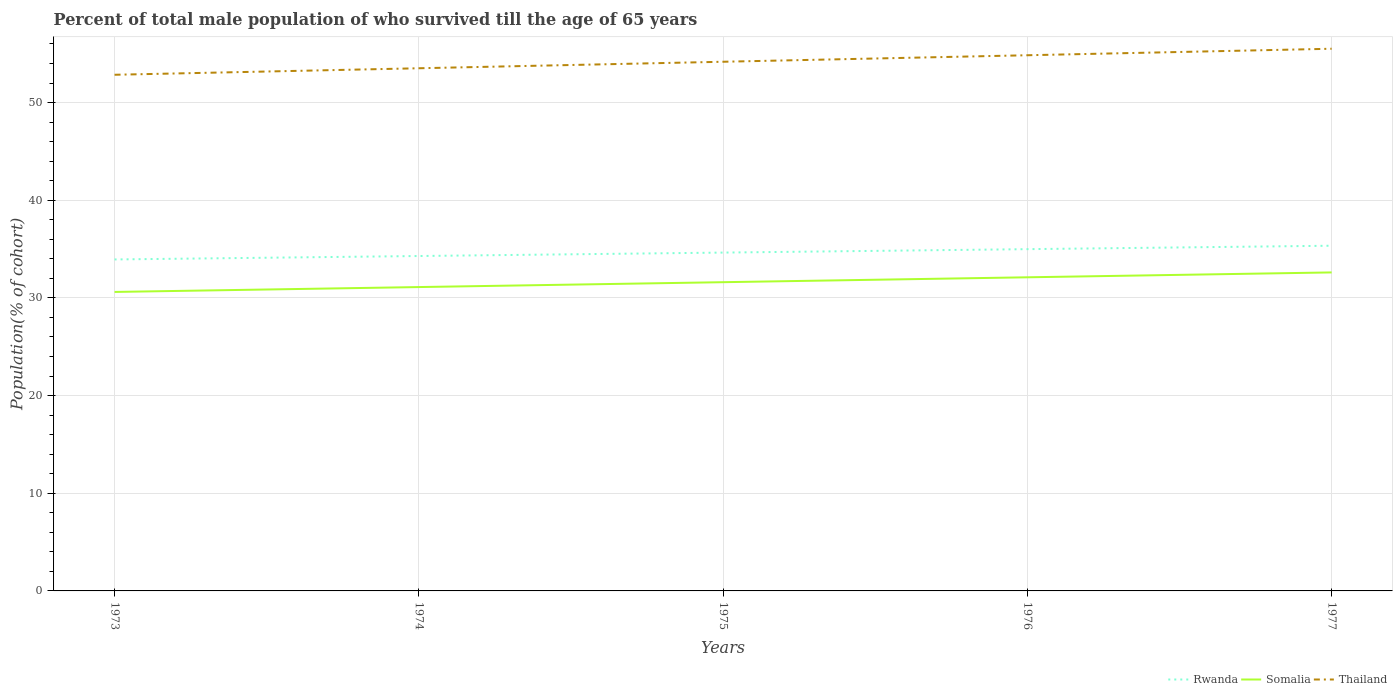How many different coloured lines are there?
Keep it short and to the point. 3. Does the line corresponding to Rwanda intersect with the line corresponding to Somalia?
Provide a short and direct response. No. Across all years, what is the maximum percentage of total male population who survived till the age of 65 years in Thailand?
Keep it short and to the point. 52.85. In which year was the percentage of total male population who survived till the age of 65 years in Somalia maximum?
Provide a short and direct response. 1973. What is the total percentage of total male population who survived till the age of 65 years in Rwanda in the graph?
Your answer should be compact. -1.05. What is the difference between the highest and the second highest percentage of total male population who survived till the age of 65 years in Rwanda?
Ensure brevity in your answer.  1.4. What is the difference between the highest and the lowest percentage of total male population who survived till the age of 65 years in Thailand?
Provide a succinct answer. 2. Is the percentage of total male population who survived till the age of 65 years in Thailand strictly greater than the percentage of total male population who survived till the age of 65 years in Rwanda over the years?
Your response must be concise. No. How many lines are there?
Give a very brief answer. 3. Are the values on the major ticks of Y-axis written in scientific E-notation?
Offer a terse response. No. Where does the legend appear in the graph?
Offer a very short reply. Bottom right. What is the title of the graph?
Give a very brief answer. Percent of total male population of who survived till the age of 65 years. Does "Dominican Republic" appear as one of the legend labels in the graph?
Keep it short and to the point. No. What is the label or title of the Y-axis?
Your answer should be very brief. Population(% of cohort). What is the Population(% of cohort) of Rwanda in 1973?
Keep it short and to the point. 33.94. What is the Population(% of cohort) of Somalia in 1973?
Offer a terse response. 30.61. What is the Population(% of cohort) in Thailand in 1973?
Offer a very short reply. 52.85. What is the Population(% of cohort) in Rwanda in 1974?
Your answer should be very brief. 34.29. What is the Population(% of cohort) in Somalia in 1974?
Keep it short and to the point. 31.11. What is the Population(% of cohort) in Thailand in 1974?
Your answer should be very brief. 53.51. What is the Population(% of cohort) in Rwanda in 1975?
Provide a succinct answer. 34.64. What is the Population(% of cohort) in Somalia in 1975?
Your answer should be compact. 31.61. What is the Population(% of cohort) in Thailand in 1975?
Your answer should be very brief. 54.18. What is the Population(% of cohort) of Rwanda in 1976?
Your answer should be compact. 34.99. What is the Population(% of cohort) in Somalia in 1976?
Your answer should be compact. 32.11. What is the Population(% of cohort) of Thailand in 1976?
Ensure brevity in your answer.  54.85. What is the Population(% of cohort) of Rwanda in 1977?
Provide a succinct answer. 35.34. What is the Population(% of cohort) in Somalia in 1977?
Give a very brief answer. 32.61. What is the Population(% of cohort) in Thailand in 1977?
Give a very brief answer. 55.51. Across all years, what is the maximum Population(% of cohort) in Rwanda?
Provide a succinct answer. 35.34. Across all years, what is the maximum Population(% of cohort) in Somalia?
Keep it short and to the point. 32.61. Across all years, what is the maximum Population(% of cohort) in Thailand?
Your response must be concise. 55.51. Across all years, what is the minimum Population(% of cohort) of Rwanda?
Ensure brevity in your answer.  33.94. Across all years, what is the minimum Population(% of cohort) in Somalia?
Your answer should be very brief. 30.61. Across all years, what is the minimum Population(% of cohort) in Thailand?
Keep it short and to the point. 52.85. What is the total Population(% of cohort) of Rwanda in the graph?
Your answer should be compact. 173.2. What is the total Population(% of cohort) of Somalia in the graph?
Your answer should be compact. 158.05. What is the total Population(% of cohort) of Thailand in the graph?
Provide a succinct answer. 270.89. What is the difference between the Population(% of cohort) of Rwanda in 1973 and that in 1974?
Provide a short and direct response. -0.35. What is the difference between the Population(% of cohort) of Somalia in 1973 and that in 1974?
Your response must be concise. -0.5. What is the difference between the Population(% of cohort) in Thailand in 1973 and that in 1974?
Your response must be concise. -0.67. What is the difference between the Population(% of cohort) of Rwanda in 1973 and that in 1975?
Offer a very short reply. -0.7. What is the difference between the Population(% of cohort) in Somalia in 1973 and that in 1975?
Offer a very short reply. -1. What is the difference between the Population(% of cohort) in Thailand in 1973 and that in 1975?
Give a very brief answer. -1.33. What is the difference between the Population(% of cohort) of Rwanda in 1973 and that in 1976?
Offer a terse response. -1.05. What is the difference between the Population(% of cohort) in Somalia in 1973 and that in 1976?
Offer a terse response. -1.5. What is the difference between the Population(% of cohort) of Thailand in 1973 and that in 1976?
Your answer should be very brief. -2. What is the difference between the Population(% of cohort) of Rwanda in 1973 and that in 1977?
Your answer should be very brief. -1.4. What is the difference between the Population(% of cohort) of Somalia in 1973 and that in 1977?
Your answer should be very brief. -2. What is the difference between the Population(% of cohort) in Thailand in 1973 and that in 1977?
Keep it short and to the point. -2.66. What is the difference between the Population(% of cohort) in Rwanda in 1974 and that in 1975?
Provide a short and direct response. -0.35. What is the difference between the Population(% of cohort) of Somalia in 1974 and that in 1975?
Offer a very short reply. -0.5. What is the difference between the Population(% of cohort) of Thailand in 1974 and that in 1975?
Ensure brevity in your answer.  -0.67. What is the difference between the Population(% of cohort) of Rwanda in 1974 and that in 1976?
Keep it short and to the point. -0.7. What is the difference between the Population(% of cohort) of Somalia in 1974 and that in 1976?
Your response must be concise. -1. What is the difference between the Population(% of cohort) of Thailand in 1974 and that in 1976?
Provide a succinct answer. -1.33. What is the difference between the Population(% of cohort) of Rwanda in 1974 and that in 1977?
Give a very brief answer. -1.05. What is the difference between the Population(% of cohort) in Somalia in 1974 and that in 1977?
Provide a succinct answer. -1.5. What is the difference between the Population(% of cohort) of Thailand in 1974 and that in 1977?
Ensure brevity in your answer.  -2. What is the difference between the Population(% of cohort) in Rwanda in 1975 and that in 1976?
Offer a terse response. -0.35. What is the difference between the Population(% of cohort) of Somalia in 1975 and that in 1976?
Your answer should be compact. -0.5. What is the difference between the Population(% of cohort) in Thailand in 1975 and that in 1976?
Offer a terse response. -0.67. What is the difference between the Population(% of cohort) of Rwanda in 1975 and that in 1977?
Ensure brevity in your answer.  -0.7. What is the difference between the Population(% of cohort) in Somalia in 1975 and that in 1977?
Keep it short and to the point. -1. What is the difference between the Population(% of cohort) in Thailand in 1975 and that in 1977?
Provide a short and direct response. -1.33. What is the difference between the Population(% of cohort) in Rwanda in 1976 and that in 1977?
Give a very brief answer. -0.35. What is the difference between the Population(% of cohort) in Somalia in 1976 and that in 1977?
Make the answer very short. -0.5. What is the difference between the Population(% of cohort) in Thailand in 1976 and that in 1977?
Ensure brevity in your answer.  -0.67. What is the difference between the Population(% of cohort) in Rwanda in 1973 and the Population(% of cohort) in Somalia in 1974?
Your answer should be very brief. 2.83. What is the difference between the Population(% of cohort) in Rwanda in 1973 and the Population(% of cohort) in Thailand in 1974?
Ensure brevity in your answer.  -19.57. What is the difference between the Population(% of cohort) in Somalia in 1973 and the Population(% of cohort) in Thailand in 1974?
Offer a very short reply. -22.9. What is the difference between the Population(% of cohort) of Rwanda in 1973 and the Population(% of cohort) of Somalia in 1975?
Provide a short and direct response. 2.33. What is the difference between the Population(% of cohort) in Rwanda in 1973 and the Population(% of cohort) in Thailand in 1975?
Provide a succinct answer. -20.24. What is the difference between the Population(% of cohort) of Somalia in 1973 and the Population(% of cohort) of Thailand in 1975?
Offer a very short reply. -23.57. What is the difference between the Population(% of cohort) in Rwanda in 1973 and the Population(% of cohort) in Somalia in 1976?
Provide a succinct answer. 1.83. What is the difference between the Population(% of cohort) in Rwanda in 1973 and the Population(% of cohort) in Thailand in 1976?
Ensure brevity in your answer.  -20.91. What is the difference between the Population(% of cohort) of Somalia in 1973 and the Population(% of cohort) of Thailand in 1976?
Provide a succinct answer. -24.23. What is the difference between the Population(% of cohort) in Rwanda in 1973 and the Population(% of cohort) in Somalia in 1977?
Ensure brevity in your answer.  1.33. What is the difference between the Population(% of cohort) in Rwanda in 1973 and the Population(% of cohort) in Thailand in 1977?
Your response must be concise. -21.57. What is the difference between the Population(% of cohort) of Somalia in 1973 and the Population(% of cohort) of Thailand in 1977?
Give a very brief answer. -24.9. What is the difference between the Population(% of cohort) of Rwanda in 1974 and the Population(% of cohort) of Somalia in 1975?
Offer a terse response. 2.68. What is the difference between the Population(% of cohort) of Rwanda in 1974 and the Population(% of cohort) of Thailand in 1975?
Offer a very short reply. -19.89. What is the difference between the Population(% of cohort) in Somalia in 1974 and the Population(% of cohort) in Thailand in 1975?
Your response must be concise. -23.07. What is the difference between the Population(% of cohort) in Rwanda in 1974 and the Population(% of cohort) in Somalia in 1976?
Your response must be concise. 2.18. What is the difference between the Population(% of cohort) of Rwanda in 1974 and the Population(% of cohort) of Thailand in 1976?
Your answer should be compact. -20.56. What is the difference between the Population(% of cohort) of Somalia in 1974 and the Population(% of cohort) of Thailand in 1976?
Offer a very short reply. -23.73. What is the difference between the Population(% of cohort) in Rwanda in 1974 and the Population(% of cohort) in Somalia in 1977?
Keep it short and to the point. 1.68. What is the difference between the Population(% of cohort) in Rwanda in 1974 and the Population(% of cohort) in Thailand in 1977?
Your answer should be compact. -21.22. What is the difference between the Population(% of cohort) of Somalia in 1974 and the Population(% of cohort) of Thailand in 1977?
Your answer should be compact. -24.4. What is the difference between the Population(% of cohort) in Rwanda in 1975 and the Population(% of cohort) in Somalia in 1976?
Offer a terse response. 2.53. What is the difference between the Population(% of cohort) of Rwanda in 1975 and the Population(% of cohort) of Thailand in 1976?
Your answer should be very brief. -20.2. What is the difference between the Population(% of cohort) of Somalia in 1975 and the Population(% of cohort) of Thailand in 1976?
Give a very brief answer. -23.24. What is the difference between the Population(% of cohort) of Rwanda in 1975 and the Population(% of cohort) of Somalia in 1977?
Make the answer very short. 2.03. What is the difference between the Population(% of cohort) of Rwanda in 1975 and the Population(% of cohort) of Thailand in 1977?
Offer a terse response. -20.87. What is the difference between the Population(% of cohort) in Somalia in 1975 and the Population(% of cohort) in Thailand in 1977?
Offer a very short reply. -23.9. What is the difference between the Population(% of cohort) in Rwanda in 1976 and the Population(% of cohort) in Somalia in 1977?
Your answer should be compact. 2.38. What is the difference between the Population(% of cohort) in Rwanda in 1976 and the Population(% of cohort) in Thailand in 1977?
Keep it short and to the point. -20.52. What is the difference between the Population(% of cohort) of Somalia in 1976 and the Population(% of cohort) of Thailand in 1977?
Your answer should be compact. -23.4. What is the average Population(% of cohort) of Rwanda per year?
Keep it short and to the point. 34.64. What is the average Population(% of cohort) of Somalia per year?
Provide a short and direct response. 31.61. What is the average Population(% of cohort) in Thailand per year?
Provide a short and direct response. 54.18. In the year 1973, what is the difference between the Population(% of cohort) in Rwanda and Population(% of cohort) in Somalia?
Your answer should be very brief. 3.33. In the year 1973, what is the difference between the Population(% of cohort) in Rwanda and Population(% of cohort) in Thailand?
Give a very brief answer. -18.91. In the year 1973, what is the difference between the Population(% of cohort) in Somalia and Population(% of cohort) in Thailand?
Your answer should be very brief. -22.24. In the year 1974, what is the difference between the Population(% of cohort) of Rwanda and Population(% of cohort) of Somalia?
Offer a very short reply. 3.18. In the year 1974, what is the difference between the Population(% of cohort) of Rwanda and Population(% of cohort) of Thailand?
Keep it short and to the point. -19.22. In the year 1974, what is the difference between the Population(% of cohort) in Somalia and Population(% of cohort) in Thailand?
Your answer should be very brief. -22.4. In the year 1975, what is the difference between the Population(% of cohort) of Rwanda and Population(% of cohort) of Somalia?
Your answer should be very brief. 3.03. In the year 1975, what is the difference between the Population(% of cohort) of Rwanda and Population(% of cohort) of Thailand?
Give a very brief answer. -19.54. In the year 1975, what is the difference between the Population(% of cohort) in Somalia and Population(% of cohort) in Thailand?
Keep it short and to the point. -22.57. In the year 1976, what is the difference between the Population(% of cohort) of Rwanda and Population(% of cohort) of Somalia?
Keep it short and to the point. 2.88. In the year 1976, what is the difference between the Population(% of cohort) in Rwanda and Population(% of cohort) in Thailand?
Your response must be concise. -19.85. In the year 1976, what is the difference between the Population(% of cohort) of Somalia and Population(% of cohort) of Thailand?
Make the answer very short. -22.74. In the year 1977, what is the difference between the Population(% of cohort) in Rwanda and Population(% of cohort) in Somalia?
Make the answer very short. 2.73. In the year 1977, what is the difference between the Population(% of cohort) of Rwanda and Population(% of cohort) of Thailand?
Provide a succinct answer. -20.17. In the year 1977, what is the difference between the Population(% of cohort) in Somalia and Population(% of cohort) in Thailand?
Your answer should be very brief. -22.9. What is the ratio of the Population(% of cohort) of Rwanda in 1973 to that in 1974?
Provide a short and direct response. 0.99. What is the ratio of the Population(% of cohort) in Somalia in 1973 to that in 1974?
Your response must be concise. 0.98. What is the ratio of the Population(% of cohort) in Thailand in 1973 to that in 1974?
Offer a terse response. 0.99. What is the ratio of the Population(% of cohort) in Rwanda in 1973 to that in 1975?
Your answer should be compact. 0.98. What is the ratio of the Population(% of cohort) in Somalia in 1973 to that in 1975?
Your response must be concise. 0.97. What is the ratio of the Population(% of cohort) in Thailand in 1973 to that in 1975?
Keep it short and to the point. 0.98. What is the ratio of the Population(% of cohort) in Rwanda in 1973 to that in 1976?
Provide a short and direct response. 0.97. What is the ratio of the Population(% of cohort) of Somalia in 1973 to that in 1976?
Keep it short and to the point. 0.95. What is the ratio of the Population(% of cohort) of Thailand in 1973 to that in 1976?
Your response must be concise. 0.96. What is the ratio of the Population(% of cohort) in Rwanda in 1973 to that in 1977?
Provide a succinct answer. 0.96. What is the ratio of the Population(% of cohort) of Somalia in 1973 to that in 1977?
Offer a terse response. 0.94. What is the ratio of the Population(% of cohort) of Thailand in 1973 to that in 1977?
Your response must be concise. 0.95. What is the ratio of the Population(% of cohort) of Somalia in 1974 to that in 1975?
Your answer should be compact. 0.98. What is the ratio of the Population(% of cohort) of Rwanda in 1974 to that in 1976?
Offer a terse response. 0.98. What is the ratio of the Population(% of cohort) of Somalia in 1974 to that in 1976?
Offer a very short reply. 0.97. What is the ratio of the Population(% of cohort) in Thailand in 1974 to that in 1976?
Give a very brief answer. 0.98. What is the ratio of the Population(% of cohort) of Rwanda in 1974 to that in 1977?
Your answer should be very brief. 0.97. What is the ratio of the Population(% of cohort) in Somalia in 1974 to that in 1977?
Give a very brief answer. 0.95. What is the ratio of the Population(% of cohort) of Thailand in 1974 to that in 1977?
Keep it short and to the point. 0.96. What is the ratio of the Population(% of cohort) of Rwanda in 1975 to that in 1976?
Provide a succinct answer. 0.99. What is the ratio of the Population(% of cohort) of Somalia in 1975 to that in 1976?
Your response must be concise. 0.98. What is the ratio of the Population(% of cohort) of Thailand in 1975 to that in 1976?
Your answer should be compact. 0.99. What is the ratio of the Population(% of cohort) in Rwanda in 1975 to that in 1977?
Provide a succinct answer. 0.98. What is the ratio of the Population(% of cohort) in Somalia in 1975 to that in 1977?
Your response must be concise. 0.97. What is the ratio of the Population(% of cohort) in Thailand in 1975 to that in 1977?
Provide a succinct answer. 0.98. What is the ratio of the Population(% of cohort) in Rwanda in 1976 to that in 1977?
Offer a terse response. 0.99. What is the ratio of the Population(% of cohort) in Somalia in 1976 to that in 1977?
Make the answer very short. 0.98. What is the difference between the highest and the second highest Population(% of cohort) in Rwanda?
Make the answer very short. 0.35. What is the difference between the highest and the second highest Population(% of cohort) in Somalia?
Keep it short and to the point. 0.5. What is the difference between the highest and the second highest Population(% of cohort) of Thailand?
Your response must be concise. 0.67. What is the difference between the highest and the lowest Population(% of cohort) in Rwanda?
Keep it short and to the point. 1.4. What is the difference between the highest and the lowest Population(% of cohort) in Somalia?
Provide a succinct answer. 2. What is the difference between the highest and the lowest Population(% of cohort) of Thailand?
Provide a short and direct response. 2.66. 